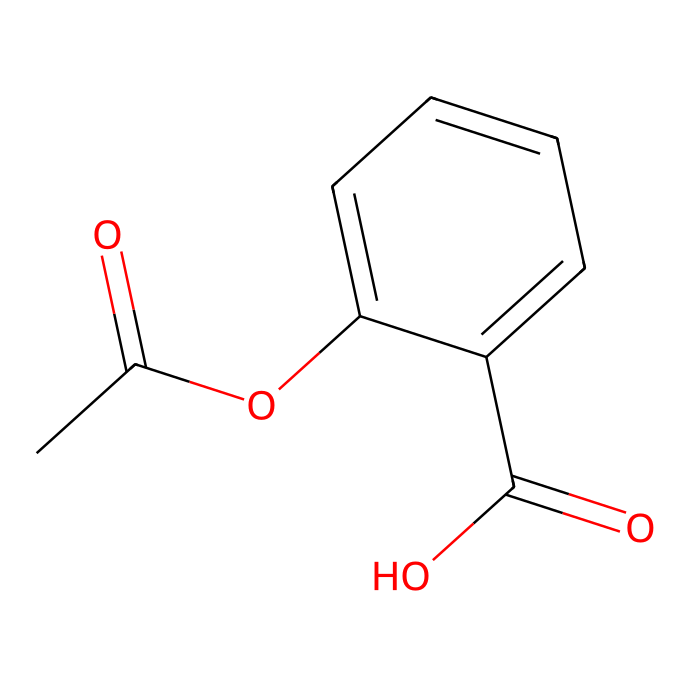What is the molecular formula of this compound? By analyzing the structure derived from the SMILES representation, we can count the number of each type of atom present. In this case, there are 10 Carbon (C), 10 Hydrogen (H), and 4 Oxygen (O) atoms. The molecular formula is thus C10H10O4.
Answer: C10H10O4 How many rings are in this chemical structure? The chemical structure includes a benzene ring, which is evident from its cyclic arrangement of carbon atoms with alternating double bonds. There is only one ring present in this structure.
Answer: 1 What type of drug activity is this compound likely associated with? The presence of acetyl and carboxylic acid functional groups suggests that this compound is likely associated with anti-inflammatory and analgesic activity, common in pain-relief medications.
Answer: anti-inflammatory What functional groups are present in this chemical? Upon examining the structure, we can identify two functional groups: an ester group (from the acetyl part) and a carboxylic acid group. This combination influences the compound's reactivity and medicinal properties.
Answer: ester and carboxylic acid What is the likely effect of this compound on pain? Given the presence of the acetyl group and the overall structure, this compound is likely to inhibit the production of prostaglandins, which are mediators of pain and inflammation, thus providing pain relief.
Answer: pain relief Does this compound have potential as an analgesic? Yes, the combination of functional groups and the structural features align with those typically found in analgesics, suggesting that it may exhibit pain-relieving properties.
Answer: yes 